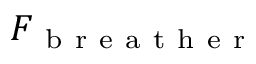<formula> <loc_0><loc_0><loc_500><loc_500>F _ { b r e a t h e r }</formula> 